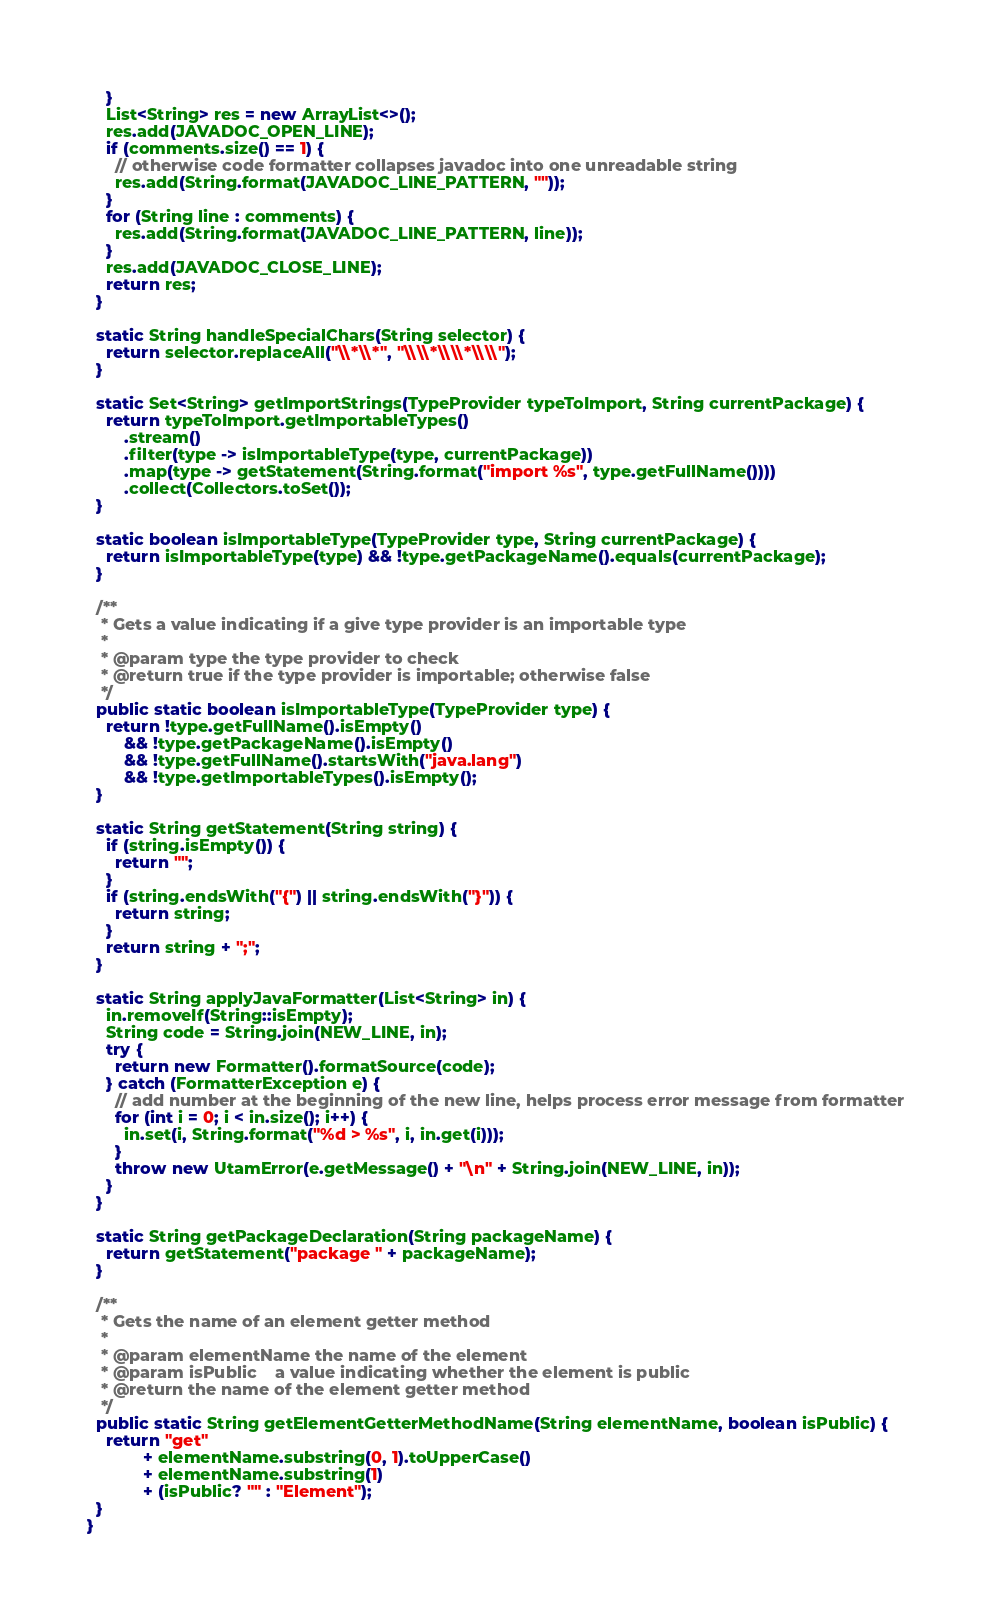<code> <loc_0><loc_0><loc_500><loc_500><_Java_>    }
    List<String> res = new ArrayList<>();
    res.add(JAVADOC_OPEN_LINE);
    if (comments.size() == 1) {
      // otherwise code formatter collapses javadoc into one unreadable string
      res.add(String.format(JAVADOC_LINE_PATTERN, ""));
    }
    for (String line : comments) {
      res.add(String.format(JAVADOC_LINE_PATTERN, line));
    }
    res.add(JAVADOC_CLOSE_LINE);
    return res;
  }

  static String handleSpecialChars(String selector) {
    return selector.replaceAll("\\*\\*", "\\\\*\\\\*\\\\");
  }

  static Set<String> getImportStrings(TypeProvider typeToImport, String currentPackage) {
    return typeToImport.getImportableTypes()
        .stream()
        .filter(type -> isImportableType(type, currentPackage))
        .map(type -> getStatement(String.format("import %s", type.getFullName())))
        .collect(Collectors.toSet());
  }

  static boolean isImportableType(TypeProvider type, String currentPackage) {
    return isImportableType(type) && !type.getPackageName().equals(currentPackage);
  }

  /**
   * Gets a value indicating if a give type provider is an importable type
   *
   * @param type the type provider to check
   * @return true if the type provider is importable; otherwise false
   */
  public static boolean isImportableType(TypeProvider type) {
    return !type.getFullName().isEmpty()
        && !type.getPackageName().isEmpty()
        && !type.getFullName().startsWith("java.lang")
        && !type.getImportableTypes().isEmpty();
  }

  static String getStatement(String string) {
    if (string.isEmpty()) {
      return "";
    }
    if (string.endsWith("{") || string.endsWith("}")) {
      return string;
    }
    return string + ";";
  }

  static String applyJavaFormatter(List<String> in) {
    in.removeIf(String::isEmpty);
    String code = String.join(NEW_LINE, in);
    try {
      return new Formatter().formatSource(code);
    } catch (FormatterException e) {
      // add number at the beginning of the new line, helps process error message from formatter
      for (int i = 0; i < in.size(); i++) {
        in.set(i, String.format("%d > %s", i, in.get(i)));
      }
      throw new UtamError(e.getMessage() + "\n" + String.join(NEW_LINE, in));
    }
  }

  static String getPackageDeclaration(String packageName) {
    return getStatement("package " + packageName);
  }

  /**
   * Gets the name of an element getter method
   *
   * @param elementName the name of the element
   * @param isPublic    a value indicating whether the element is public
   * @return the name of the element getter method
   */
  public static String getElementGetterMethodName(String elementName, boolean isPublic) {
    return "get"
            + elementName.substring(0, 1).toUpperCase()
            + elementName.substring(1)
            + (isPublic? "" : "Element");
  }
}
</code> 